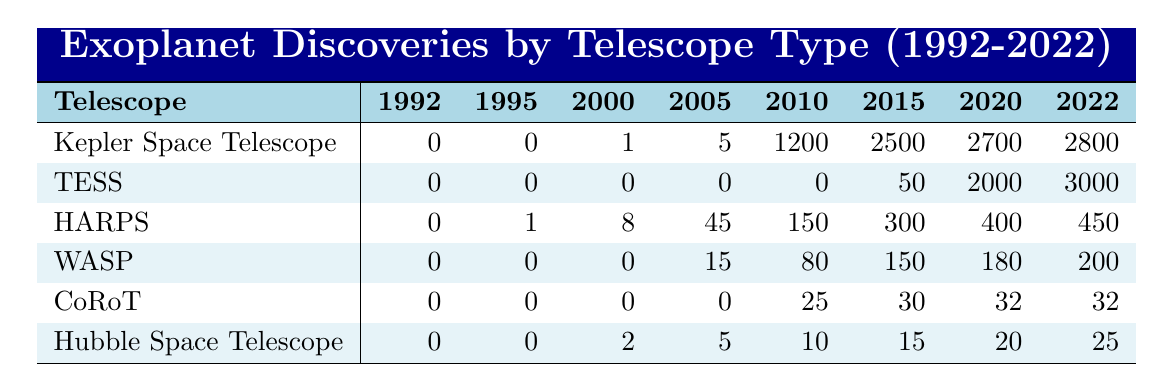What is the total number of exoplanet discoveries made by the Kepler Space Telescope by 2022? To find this, look at the row for the Kepler Space Telescope. The last value in the row is 2800, which indicates the total discoveries from 1992 to 2022.
Answer: 2800 Which telescope had the lowest number of discoveries in 2010? Check the values for each telescope in the 2010 column. CoRoT has the lowest number with 25 discoveries.
Answer: CoRoT Did TESS make any discoveries in 2005? Looking at the TESS row for the year 2005, the value is 0, which means TESS did not make any discoveries that year.
Answer: No What is the difference in discoveries between HARPS and WASP in 2005? In the 2005 column, HARPS has 45 discoveries and WASP has 15 discoveries. The difference is 45 - 15 = 30.
Answer: 30 What is the average number of discoveries made by the Hubble Space Telescope from 1992 to 2022? Sum the values from the row for the Hubble Space Telescope: 0 + 0 + 2 + 5 + 10 + 15 + 20 + 25 = 77. There are 8 years, so the average is 77/8 = 9.625.
Answer: 9.625 Based on the data, which telescope had the most significant increase in discoveries from 2010 to 2022? For each telescope, calculate the difference between the values in 2022 and 2010. For Kepler, it's 2800 - 1200 = 1600; for TESS, it's 3000 - 0 = 3000; for HARPS, it's 450 - 150 = 300; for WASP, it's 200 - 80 = 120; for CoRoT, it's 32 - 25 = 7; for Hubble, it's 25 - 10 = 15. TESS had the highest increase with 3000.
Answer: TESS Which telescope consistently had no discoveries from 1992 to 2004? Look at the rows from 1992 to 2004 for each telescope. CoRoT and TESS both have 0 discoveries from 1992 to 2004.
Answer: CoRoT and TESS What year saw the first recorded discoveries by the HARPS telescope? Look at the first non-zero value in the HARPS row. This occurs in 2000, where it has 8 discoveries.
Answer: 2000 